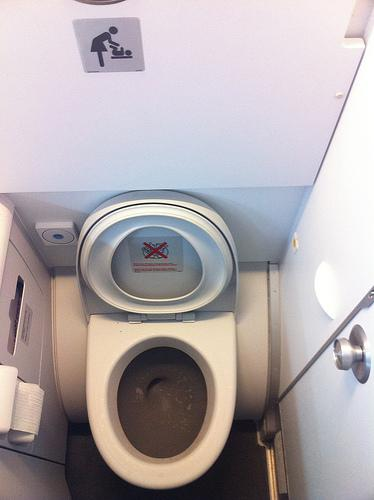Question: what is on the door?
Choices:
A. A wreath.
B. A peep hole.
C. A lock.
D. A handle.
Answer with the letter. Answer: D Question: what is hanging up?
Choices:
A. A picture.
B. Toilet paper.
C. Clothing.
D. A clean towel.
Answer with the letter. Answer: B Question: who took the photo?
Choices:
A. A photographer.
B. Her husband.
C. A stranger.
D. A passenger.
Answer with the letter. Answer: D 